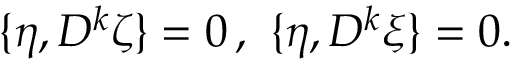<formula> <loc_0><loc_0><loc_500><loc_500>\{ \eta , D ^ { k } \zeta \} = 0 \, , \ \{ \eta , D ^ { k } \xi \} = 0 .</formula> 